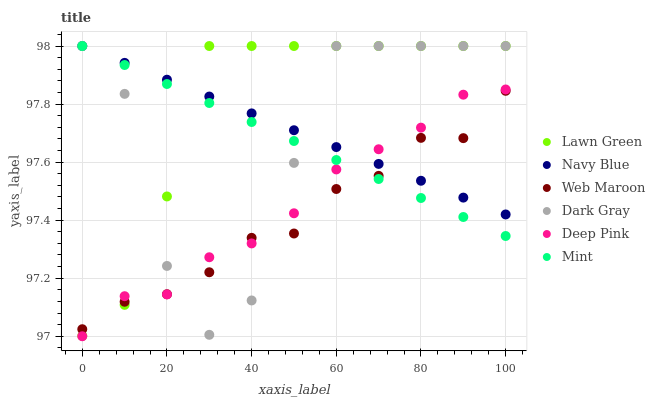Does Web Maroon have the minimum area under the curve?
Answer yes or no. Yes. Does Lawn Green have the maximum area under the curve?
Answer yes or no. Yes. Does Deep Pink have the minimum area under the curve?
Answer yes or no. No. Does Deep Pink have the maximum area under the curve?
Answer yes or no. No. Is Mint the smoothest?
Answer yes or no. Yes. Is Dark Gray the roughest?
Answer yes or no. Yes. Is Deep Pink the smoothest?
Answer yes or no. No. Is Deep Pink the roughest?
Answer yes or no. No. Does Deep Pink have the lowest value?
Answer yes or no. Yes. Does Navy Blue have the lowest value?
Answer yes or no. No. Does Mint have the highest value?
Answer yes or no. Yes. Does Deep Pink have the highest value?
Answer yes or no. No. Does Deep Pink intersect Mint?
Answer yes or no. Yes. Is Deep Pink less than Mint?
Answer yes or no. No. Is Deep Pink greater than Mint?
Answer yes or no. No. 